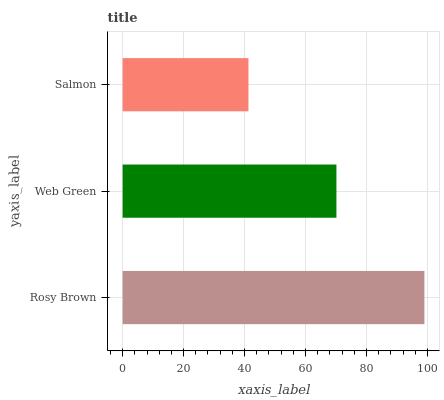Is Salmon the minimum?
Answer yes or no. Yes. Is Rosy Brown the maximum?
Answer yes or no. Yes. Is Web Green the minimum?
Answer yes or no. No. Is Web Green the maximum?
Answer yes or no. No. Is Rosy Brown greater than Web Green?
Answer yes or no. Yes. Is Web Green less than Rosy Brown?
Answer yes or no. Yes. Is Web Green greater than Rosy Brown?
Answer yes or no. No. Is Rosy Brown less than Web Green?
Answer yes or no. No. Is Web Green the high median?
Answer yes or no. Yes. Is Web Green the low median?
Answer yes or no. Yes. Is Rosy Brown the high median?
Answer yes or no. No. Is Salmon the low median?
Answer yes or no. No. 